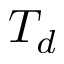Convert formula to latex. <formula><loc_0><loc_0><loc_500><loc_500>T _ { d }</formula> 